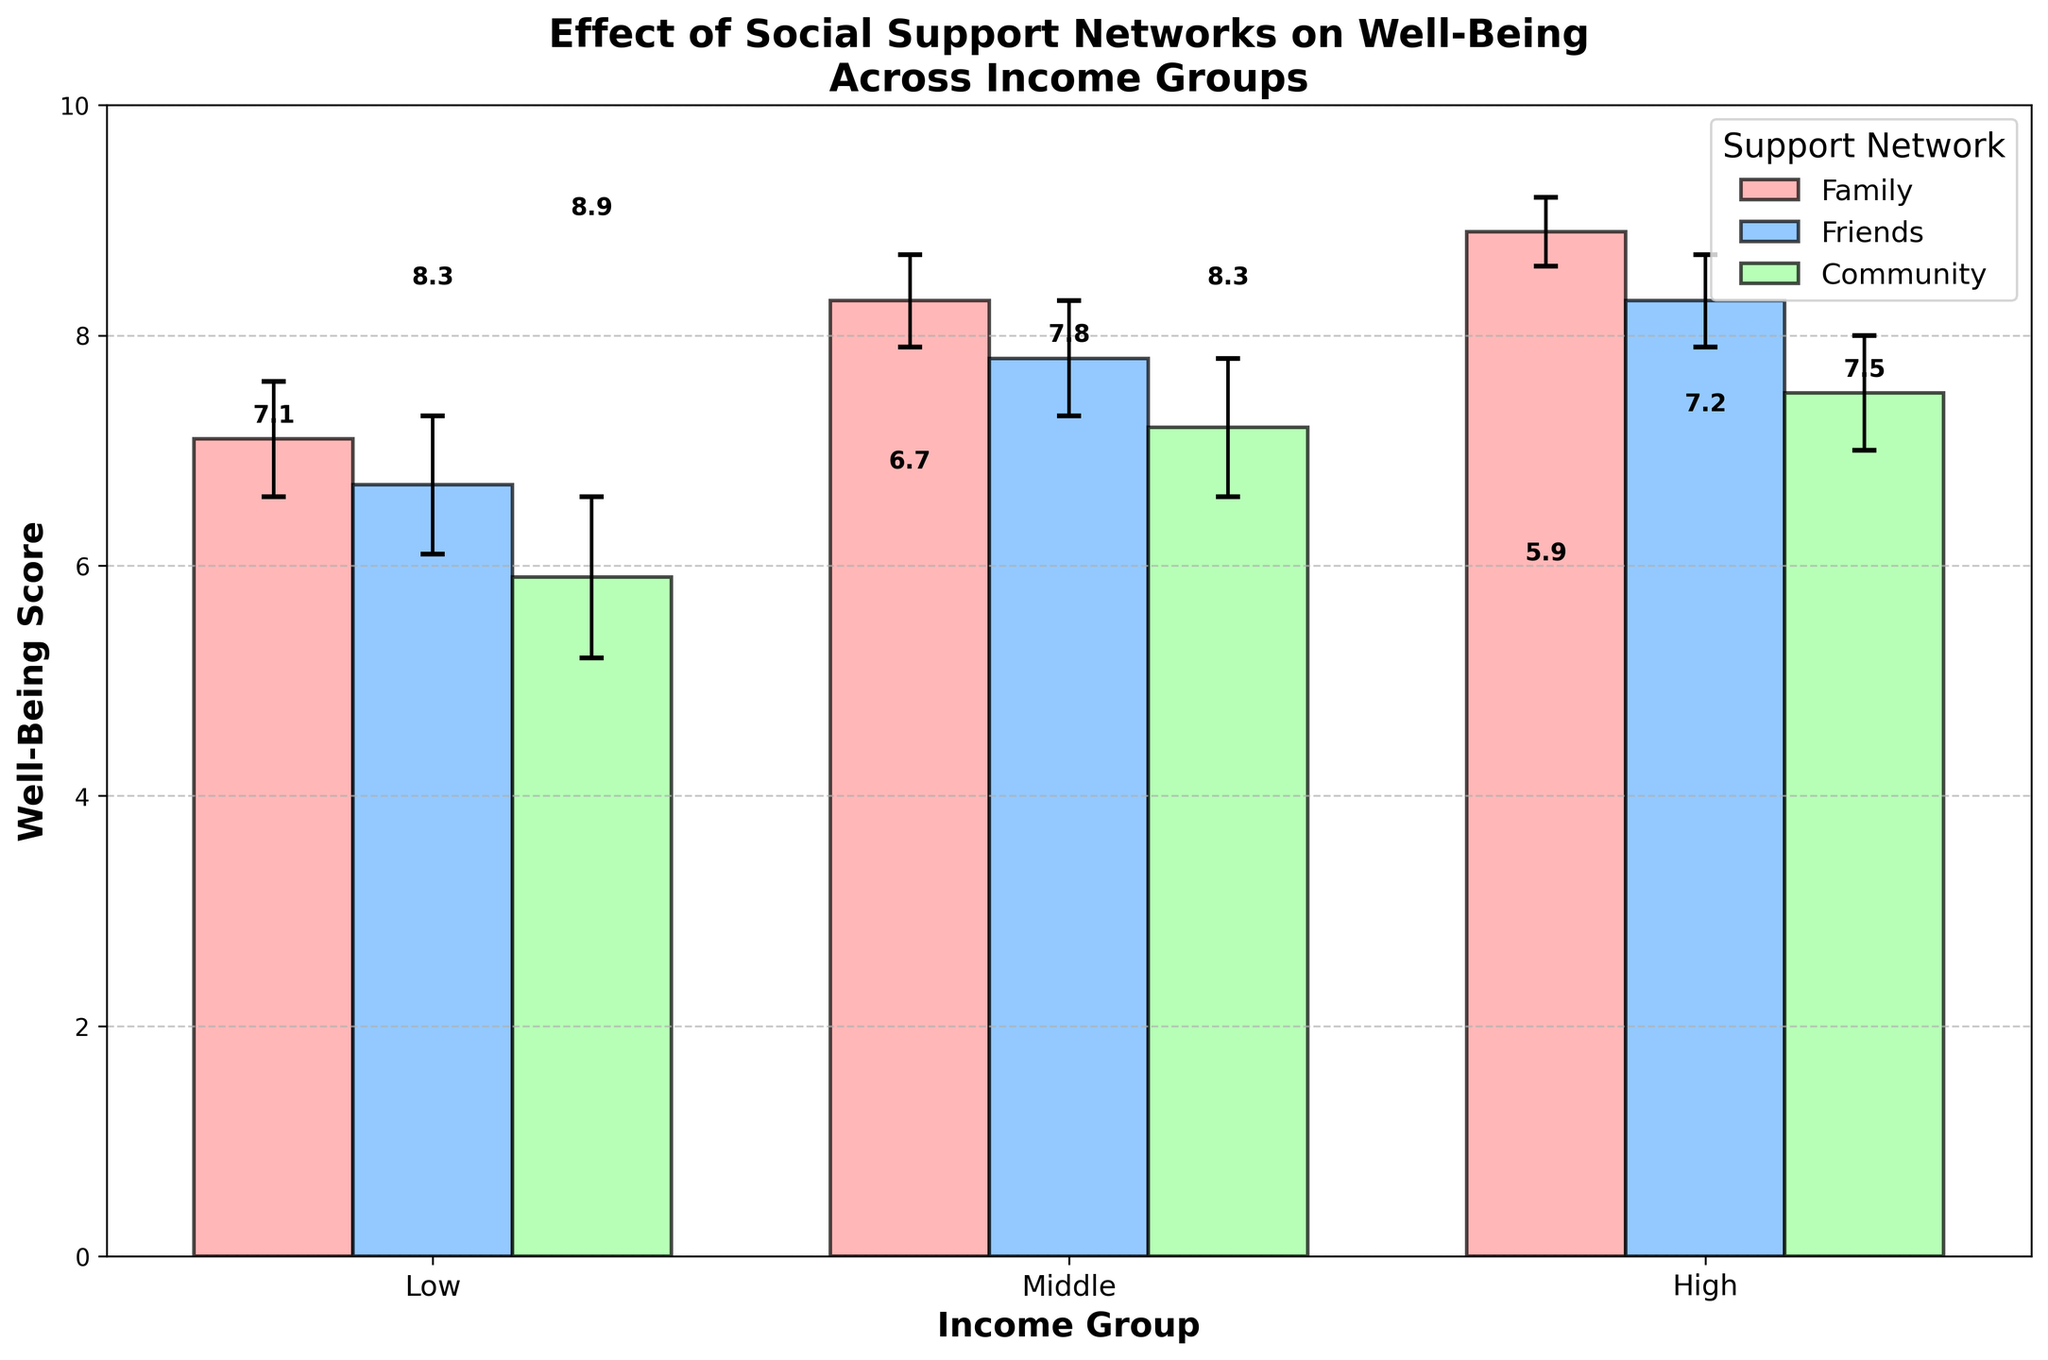What are the three income groups displayed in the figure? The x-axis in the figure features the different income groups, which are labeled as 'Low,' 'Middle,' and 'High' respectively.
Answer: Low, Middle, High Which social support network has the highest average well-being score across all income groups? We need to calculate the average of the well-being scores for 'Family,' 'Friends,' and 'Community' across all income groups. 'Family': (7.1+8.3+8.9)/3=8.1, 'Friends': (6.7+7.8+8.3)/3=7.6, 'Community': (5.9+7.2+7.5)/3=6.87. The 'Family' network has the highest average score.
Answer: Family What is the well-being score for the low-income group with the 'Friends' support network? The figure shows that the well-being score for the low-income group with the 'Friends' support network is represented by a bar reaching up to the value 6.7 on the y-axis.
Answer: 6.7 How does the well-being score for 'Community' support networks vary between low and high-income groups? Looking at the bars for 'Community' support networks across low and high-income groups, the well-being scores are 5.9 for the low-income group and 7.5 for the high-income group. The difference is 7.5 - 5.9 = 1.6.
Answer: 1.6 What is the difference in well-being scores between 'Family' and 'Community' networks for the middle-income group? The well-being score for 'Family' in the middle-income group is 8.3, and for 'Community,' it is 7.2. The difference is 8.3 - 7.2 = 1.1.
Answer: 1.1 Which social support network has the highest error margin for the well-being score in the low-income group? In the figure, the error bars for the low-income group's well-being scores are analyzed. 'Family' has an error of 0.5, 'Friends' has 0.6, and 'Community' has 0.7. 'Community' has the highest error margin.
Answer: Community Are middle-income individuals with 'Community' support networks more likely to experience higher well-being than low-income individuals with 'Family' support networks? The well-being score for middle-income individuals with 'Community' support is 7.2, while for low-income individuals with 'Family' support, it is 7.1. 7.2 is slightly greater than 7.1.
Answer: Yes Which income group displays the widest range of well-being scores across different social support networks? The low-income group's scores range from 5.9 to 7.1, the middle income from 7.2 to 8.3, and the high income from 7.5 to 8.9. The range for low is 1.2, middle is 1.1, high is 1.4. The high-income group has the widest range.
Answer: High What is the overall trend observed in well-being scores as income levels increase within 'Family' support networks? Analyzing the 'Family' bar heights across income levels: Low (7.1), Middle (8.3), High (8.9), the trend shows an increase in well-being scores as income levels rise.
Answer: Increase 